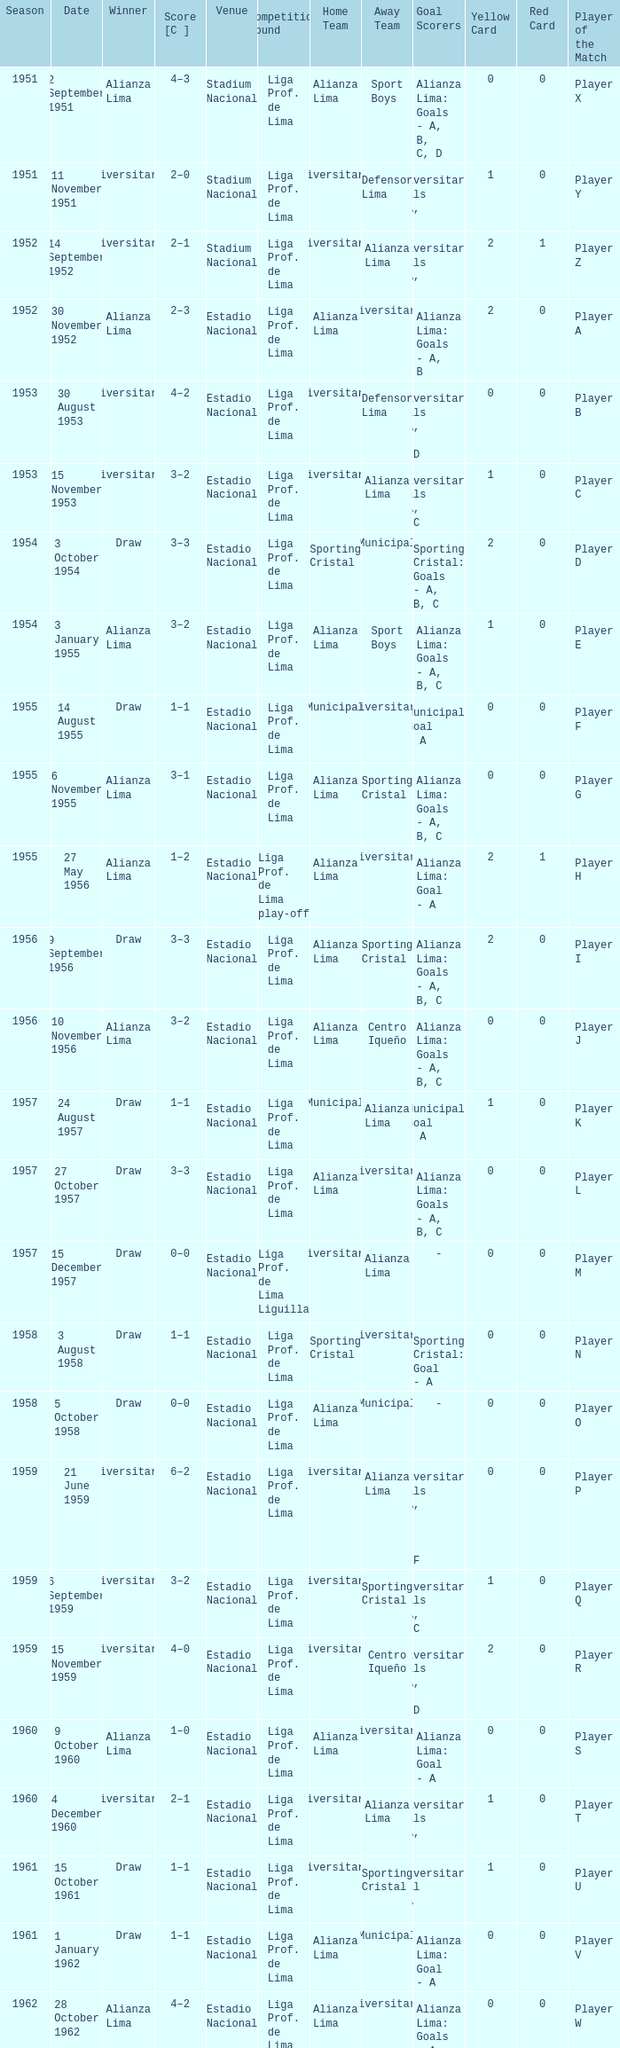What is the score of the event that Alianza Lima won in 1965? 1–0. 